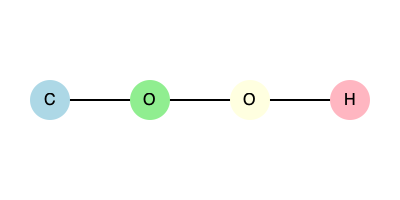Identify the molecular structure represented in the 2D diagram above and provide its IUPAC name. To identify the molecular structure and provide its IUPAC name, we'll follow these steps:

1. Analyze the diagram:
   - We see four atoms connected in a linear chain
   - The atoms are, from left to right: C, O, O, H

2. Identify the functional group:
   - Two oxygen atoms connected in sequence suggest a peroxide group (-O-O-)
   - The hydrogen at the end indicates it's a hydroperoxide

3. Determine the base structure:
   - We have one carbon atom, so this is a methyl group

4. Combine the information:
   - The structure is a methyl group attached to a hydroperoxide group

5. Apply IUPAC naming rules:
   - The base name for a one-carbon chain is "methane"
   - The suffix "-peroxol" is used for hydroperoxides
   - When the -OOH group is the principal functional group, we use the suffix directly

6. Construct the IUPAC name:
   - The correct IUPAC name is "methaneperoxol"

This molecule is also commonly known as methyl hydroperoxide, but the question specifically asks for the IUPAC name.
Answer: Methaneperoxol 